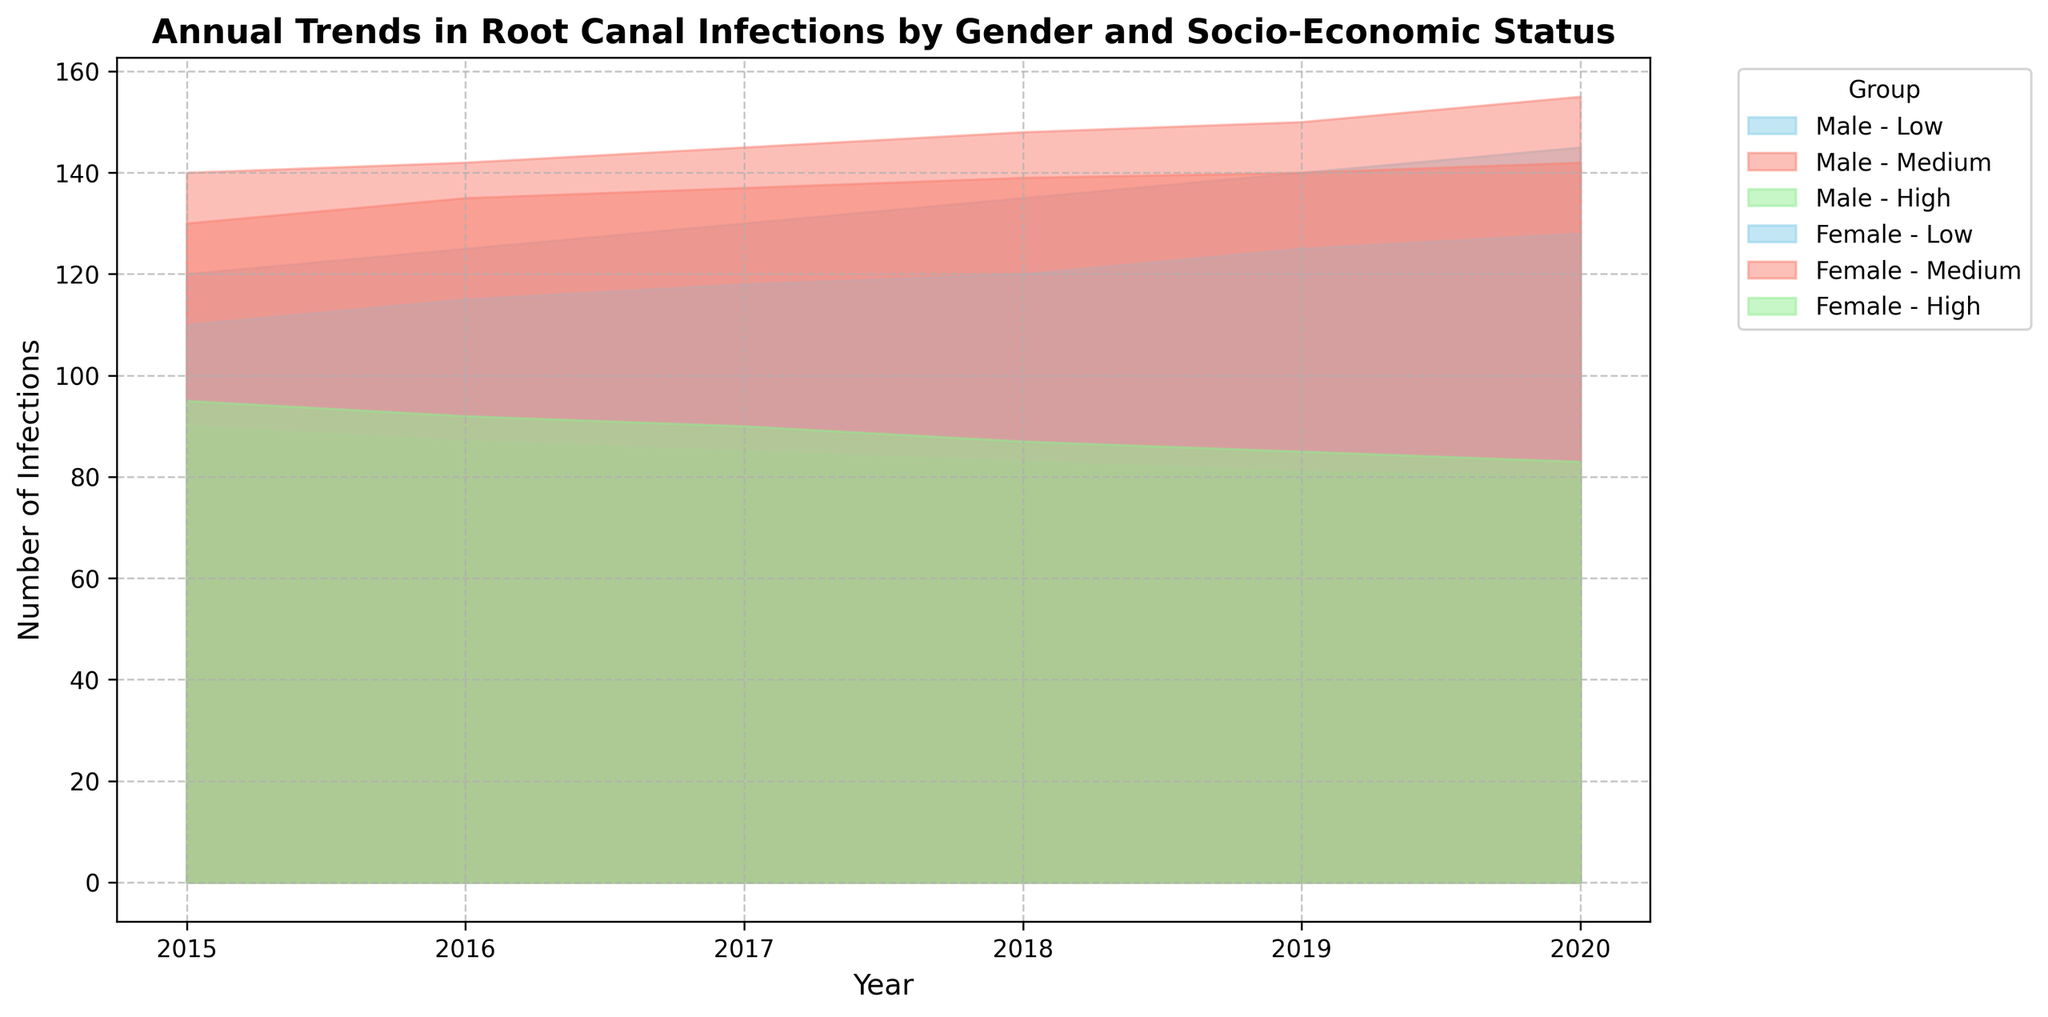What trend is observed in root canal infections for males with low socio-economic status from 2015 to 2020? By looking at the area chart for males with low socio-economic status, the number of infections consistently increases from 120 in 2015 to 145 in 2020.
Answer: Increasing trend Between males and females in the high socio-economic status, which gender had fewer infections in 2020? By examining the area chart for high socio-economic status in 2020, males had 80 infections while females had 83 infections.
Answer: Males Which socio-economic status group had the most significant increase in infections for females from 2015 to 2020? By comparing the area charts for females across different socio-economic statuses, the low status group increased from 110 in 2015 to 128 in 2020, the medium status from 130 to 142, and the high status from 95 to 83. The medium status shows the highest increase in infections (12).
Answer: Medium How do the total infections for medium socio-economic status compare between genders in 2017? For 2017, the total infections for medium socio-economic status for males is 145 and for females is 137.
Answer: Males had more infections What is the overall trend observed for infections in the high socio-economic status category from 2015 to 2020 across both genders? In the high socio-economic status category, both males and females exhibit a decreasing trend in infections from 2015 to 2020.
Answer: Decreasing Which year had the highest total number of infections for females in the low socio-economic status group? By looking at the area chart for females in the low socio-economic status group, 2019 shows the highest with 125 infections.
Answer: 2019 How does the number of infections for males with medium socio-economic status in 2020 compare to 2015? By analyzing the data for males with medium socio-economic status, the infections in 2015 were 140 and in 2020 were 155. The infections increased by 15 from 2015 to 2020.
Answer: Increased by 15 Among females, which socio-economic status showed the smallest change in the number of infections from 2015 to 2020? By comparing the numbers, high socio-economic status for females shows a decrease from 95 to 83, medium status shows an increase from 130 to 142, and low status shows an increase from 110 to 128. The high status shows the smallest change.
Answer: High What is the difference in the total number of infections between low and high socio-economic status groups for males in 2018? For males in 2018, the number of infections in the low status is 135 and in the high status is 83. The difference is 135 - 83 = 52.
Answer: 52 Which socio-economic status group for females showed a decline in the number of infections from 2015 to 2020, and by how much? For females, the high socio-economic status group showed a decline from 95 in 2015 to 83 in 2020. The decline is 95 - 83 = 12.
Answer: High, 12 